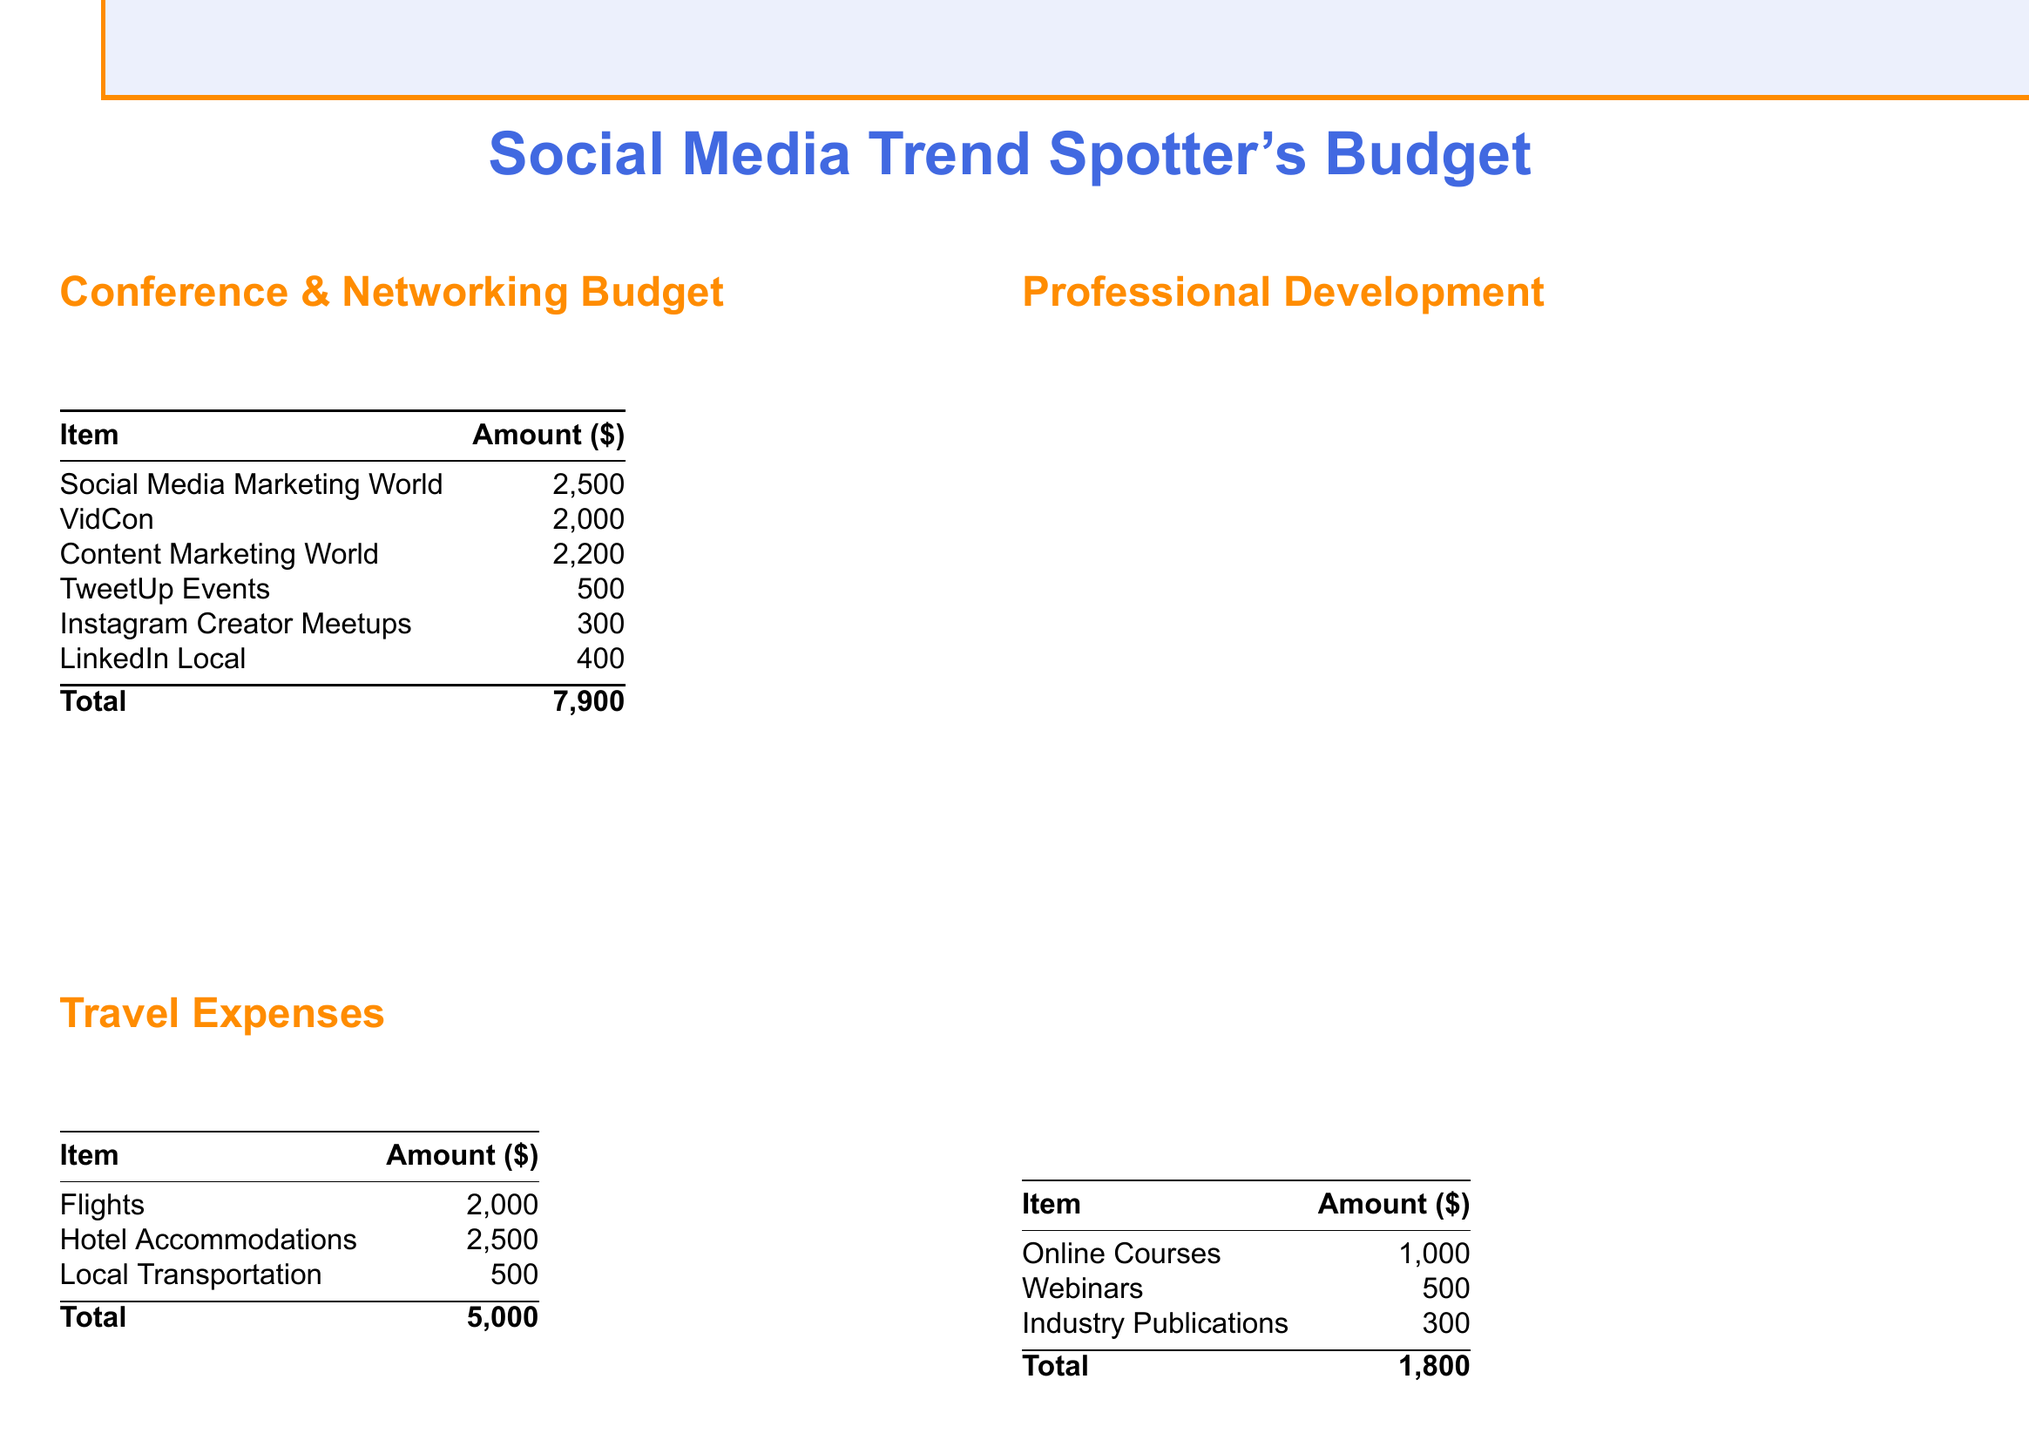What is the total budget? The total budget is the overall sum of all sections in the document, which equals $19,200.
Answer: $19,200 How much is allocated for Social Media Marketing World? The budget for Social Media Marketing World is listed as a specific item in the conference budget, which is $2,500.
Answer: $2,500 What is the amount set aside for flights? The amount allocated for flights is specified under travel expenses, which is $2,000.
Answer: $2,000 What portion of the budget is designated for online courses? The budget for online courses is outlined in the professional development section, which totals $1,000.
Answer: $1,000 What is the contingency fund total? The contingency fund total is the sum of unexpected costs in the document, specifically shown as $1,500.
Answer: $1,500 Which conference has the highest cost allocation? The conference that has the highest cost allocation is Social Media Marketing World, which costs $2,500.
Answer: Social Media Marketing World What is the total amount for travel expenses? The total travel expenses are calculated by adding all travel-related costs together, resulting in a total of $5,000.
Answer: $5,000 Which item has the least funding in the conference budget? The item with the least funding in the conference budget is Instagram Creator Meetups, allocated at $300.
Answer: Instagram Creator Meetups What is the purpose of the key performance indicators? The purpose of the key performance indicators is to measure success as outlined in the document, focusing on connections made and engagement rates.
Answer: Measure success What strategy is implemented for budget allocation? One strategy implemented for budget allocation is to prioritize events with proven ROI from previous years.
Answer: Prioritize events with proven ROI 